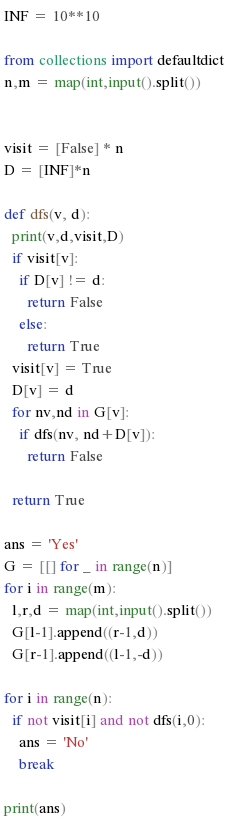<code> <loc_0><loc_0><loc_500><loc_500><_Python_>INF = 10**10

from collections import defaultdict
n,m = map(int,input().split())


visit = [False] * n
D = [INF]*n

def dfs(v, d):
  print(v,d,visit,D)
  if visit[v]:
    if D[v] != d:
      return False
    else:
      return True  
  visit[v] = True
  D[v] = d
  for nv,nd in G[v]:
    if dfs(nv, nd+D[v]):
      return False
    
  return True

ans = 'Yes'
G = [[] for _ in range(n)]
for i in range(m):
  l,r,d = map(int,input().split())
  G[l-1].append((r-1,d))
  G[r-1].append((l-1,-d))  
  
for i in range(n):
  if not visit[i] and not dfs(i,0):
    ans = 'No'
    break
  
print(ans)</code> 